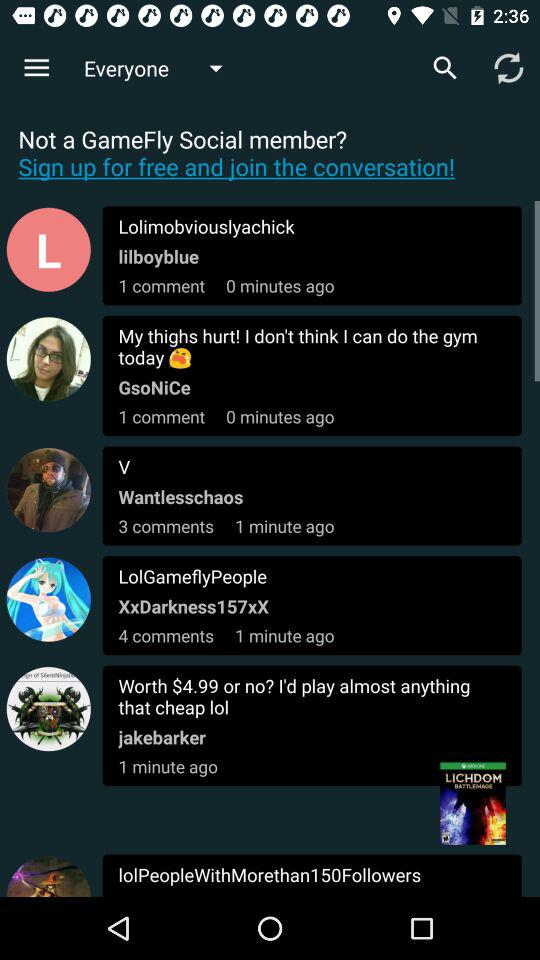How many comments are shown there for "V"? There are 3 comments shown. 